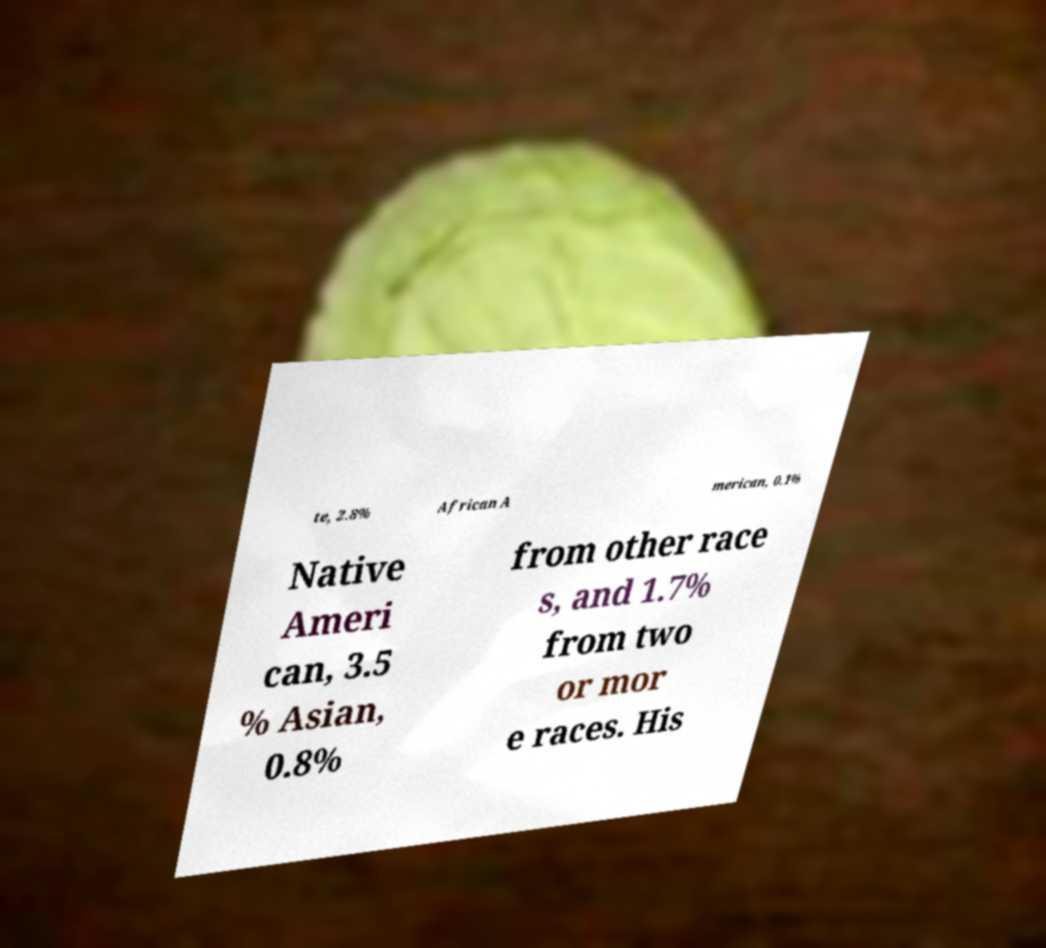Please read and relay the text visible in this image. What does it say? te, 2.8% African A merican, 0.1% Native Ameri can, 3.5 % Asian, 0.8% from other race s, and 1.7% from two or mor e races. His 